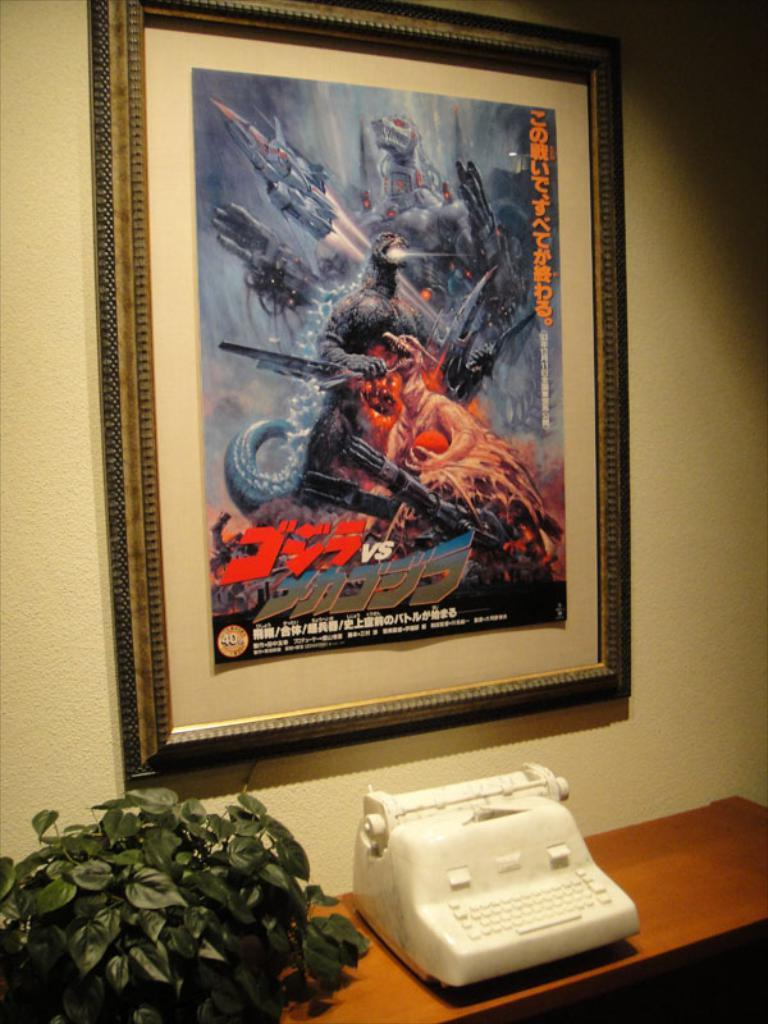What is attached to the wall in the image? There is a photo frame attached to the wall. What is located in front of the wall? There is a table in front of the wall. What can be seen on the table? There are objects on the table. What type of vegetation is beside the table? There is a plant beside the table. What type of chain is holding the plant to the table? There is no chain present in the image; the plant is beside the table, not attached to it. What event is taking place in the image? There is no specific event taking place in the image; it is a still scene featuring a photo frame, table, objects, and a plant. 